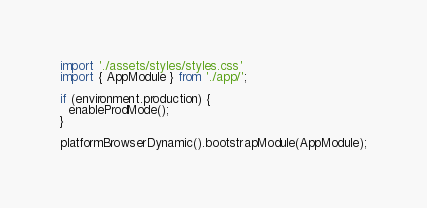Convert code to text. <code><loc_0><loc_0><loc_500><loc_500><_TypeScript_>
import './assets/styles/styles.css'
import { AppModule } from './app/';

if (environment.production) {
  enableProdMode();
}

platformBrowserDynamic().bootstrapModule(AppModule);
</code> 